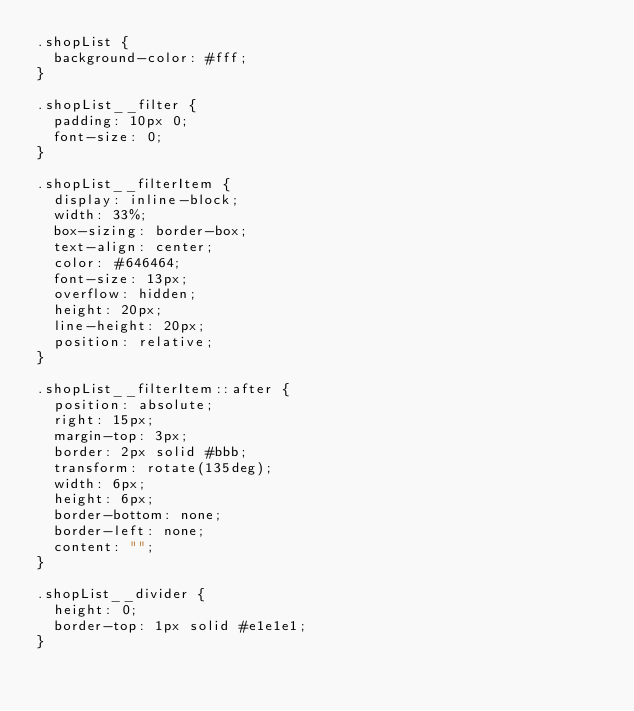Convert code to text. <code><loc_0><loc_0><loc_500><loc_500><_CSS_>.shopList {
  background-color: #fff;
}

.shopList__filter {
  padding: 10px 0;
  font-size: 0;
}

.shopList__filterItem {
  display: inline-block;
  width: 33%;
  box-sizing: border-box;
  text-align: center;
  color: #646464;
  font-size: 13px;
  overflow: hidden;
  height: 20px;
  line-height: 20px;
  position: relative;
}

.shopList__filterItem::after {
  position: absolute;
  right: 15px;
  margin-top: 3px;
  border: 2px solid #bbb;
  transform: rotate(135deg);
  width: 6px;
  height: 6px;
  border-bottom: none;
  border-left: none;
  content: "";
}

.shopList__divider {
  height: 0;
  border-top: 1px solid #e1e1e1;
}
</code> 